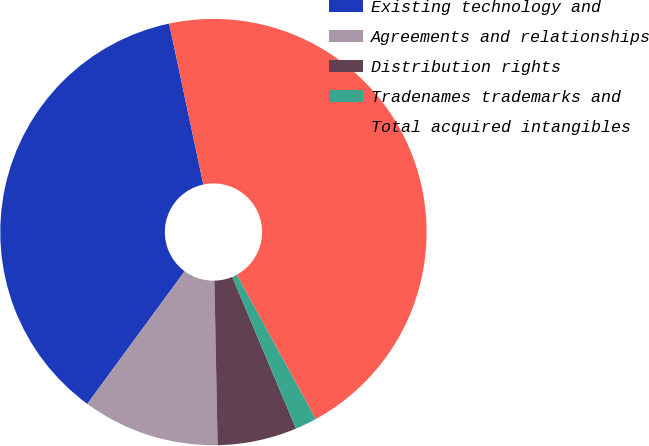<chart> <loc_0><loc_0><loc_500><loc_500><pie_chart><fcel>Existing technology and<fcel>Agreements and relationships<fcel>Distribution rights<fcel>Tradenames trademarks and<fcel>Total acquired intangibles<nl><fcel>36.59%<fcel>10.39%<fcel>6.02%<fcel>1.65%<fcel>45.35%<nl></chart> 